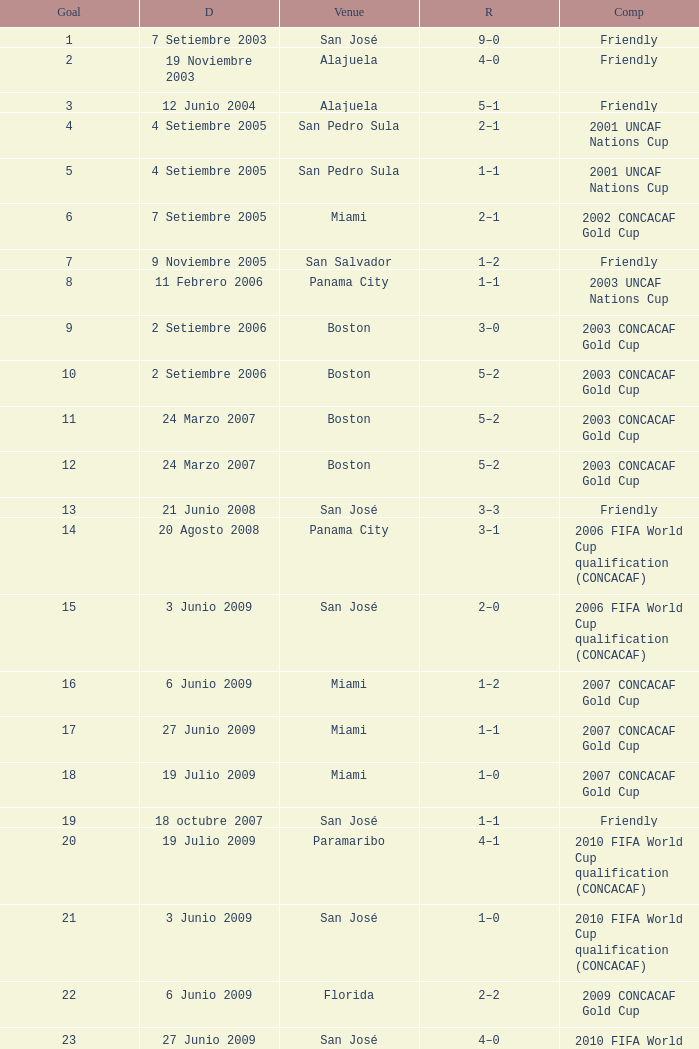At the venue of panama city, on 11 Febrero 2006, how many goals were scored? 1.0. 